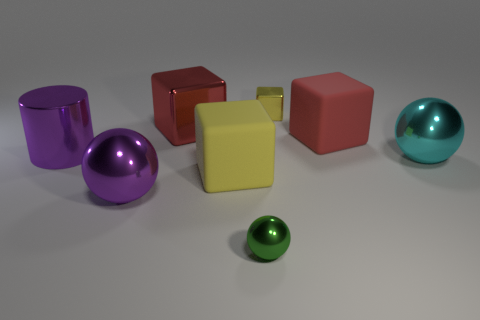There is another small object that is the same shape as the red matte thing; what material is it?
Provide a short and direct response. Metal. The large metal cube is what color?
Provide a short and direct response. Red. What color is the large matte cube in front of the purple metallic cylinder left of the purple shiny sphere?
Your answer should be very brief. Yellow. There is a tiny metallic sphere; does it have the same color as the large metal object that is behind the cylinder?
Your answer should be very brief. No. There is a red thing behind the red object that is right of the yellow matte cube; how many large red metal objects are behind it?
Offer a very short reply. 0. There is a purple metallic sphere; are there any yellow objects in front of it?
Give a very brief answer. No. Are there any other things of the same color as the large shiny cylinder?
Offer a terse response. Yes. What number of cubes are cyan metal things or small metallic things?
Your answer should be compact. 1. How many large things are both in front of the cyan sphere and behind the purple sphere?
Your answer should be compact. 1. Are there the same number of small green shiny objects to the right of the big cyan thing and purple balls that are right of the tiny green shiny thing?
Your response must be concise. Yes. 